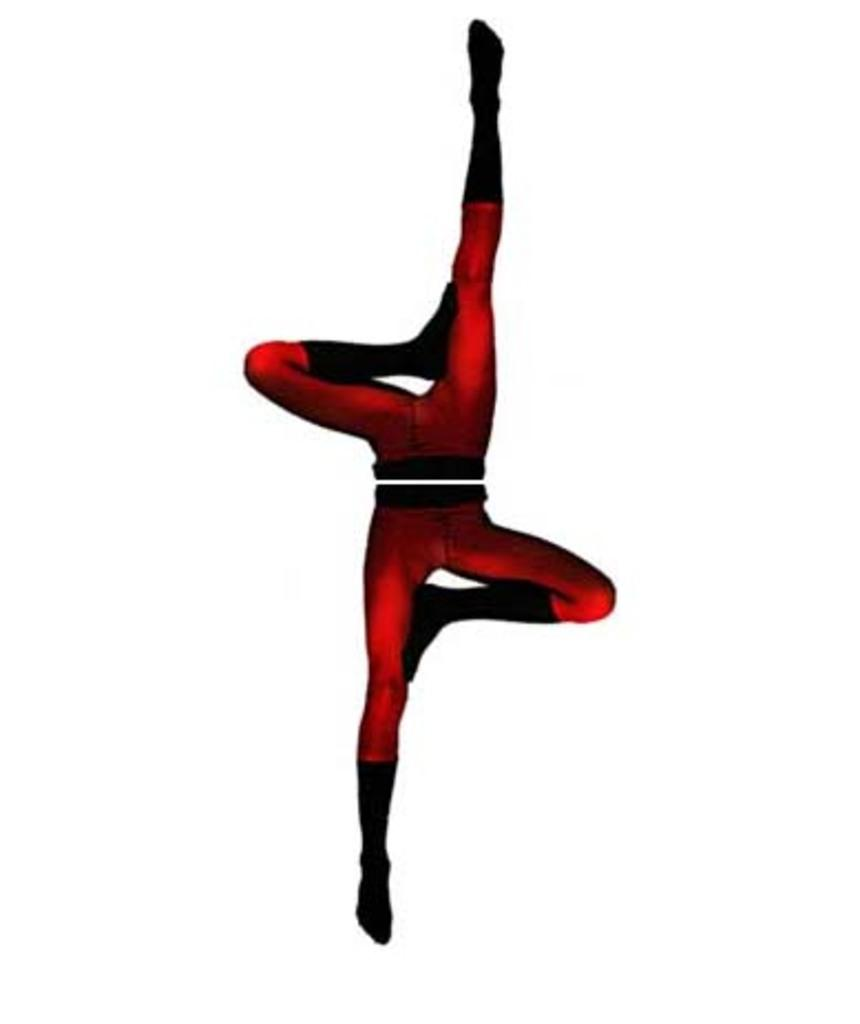What type of image is present in the picture? There is a cartoon image in the picture. What does the cartoon image depict? The cartoon image appears to depict legs of persons. What color is the background of the image? The background of the image is white. What type of curtain can be seen hanging from the structure in the image? There is no curtain or structure present in the image; it only features a cartoon image of legs and a white background. 